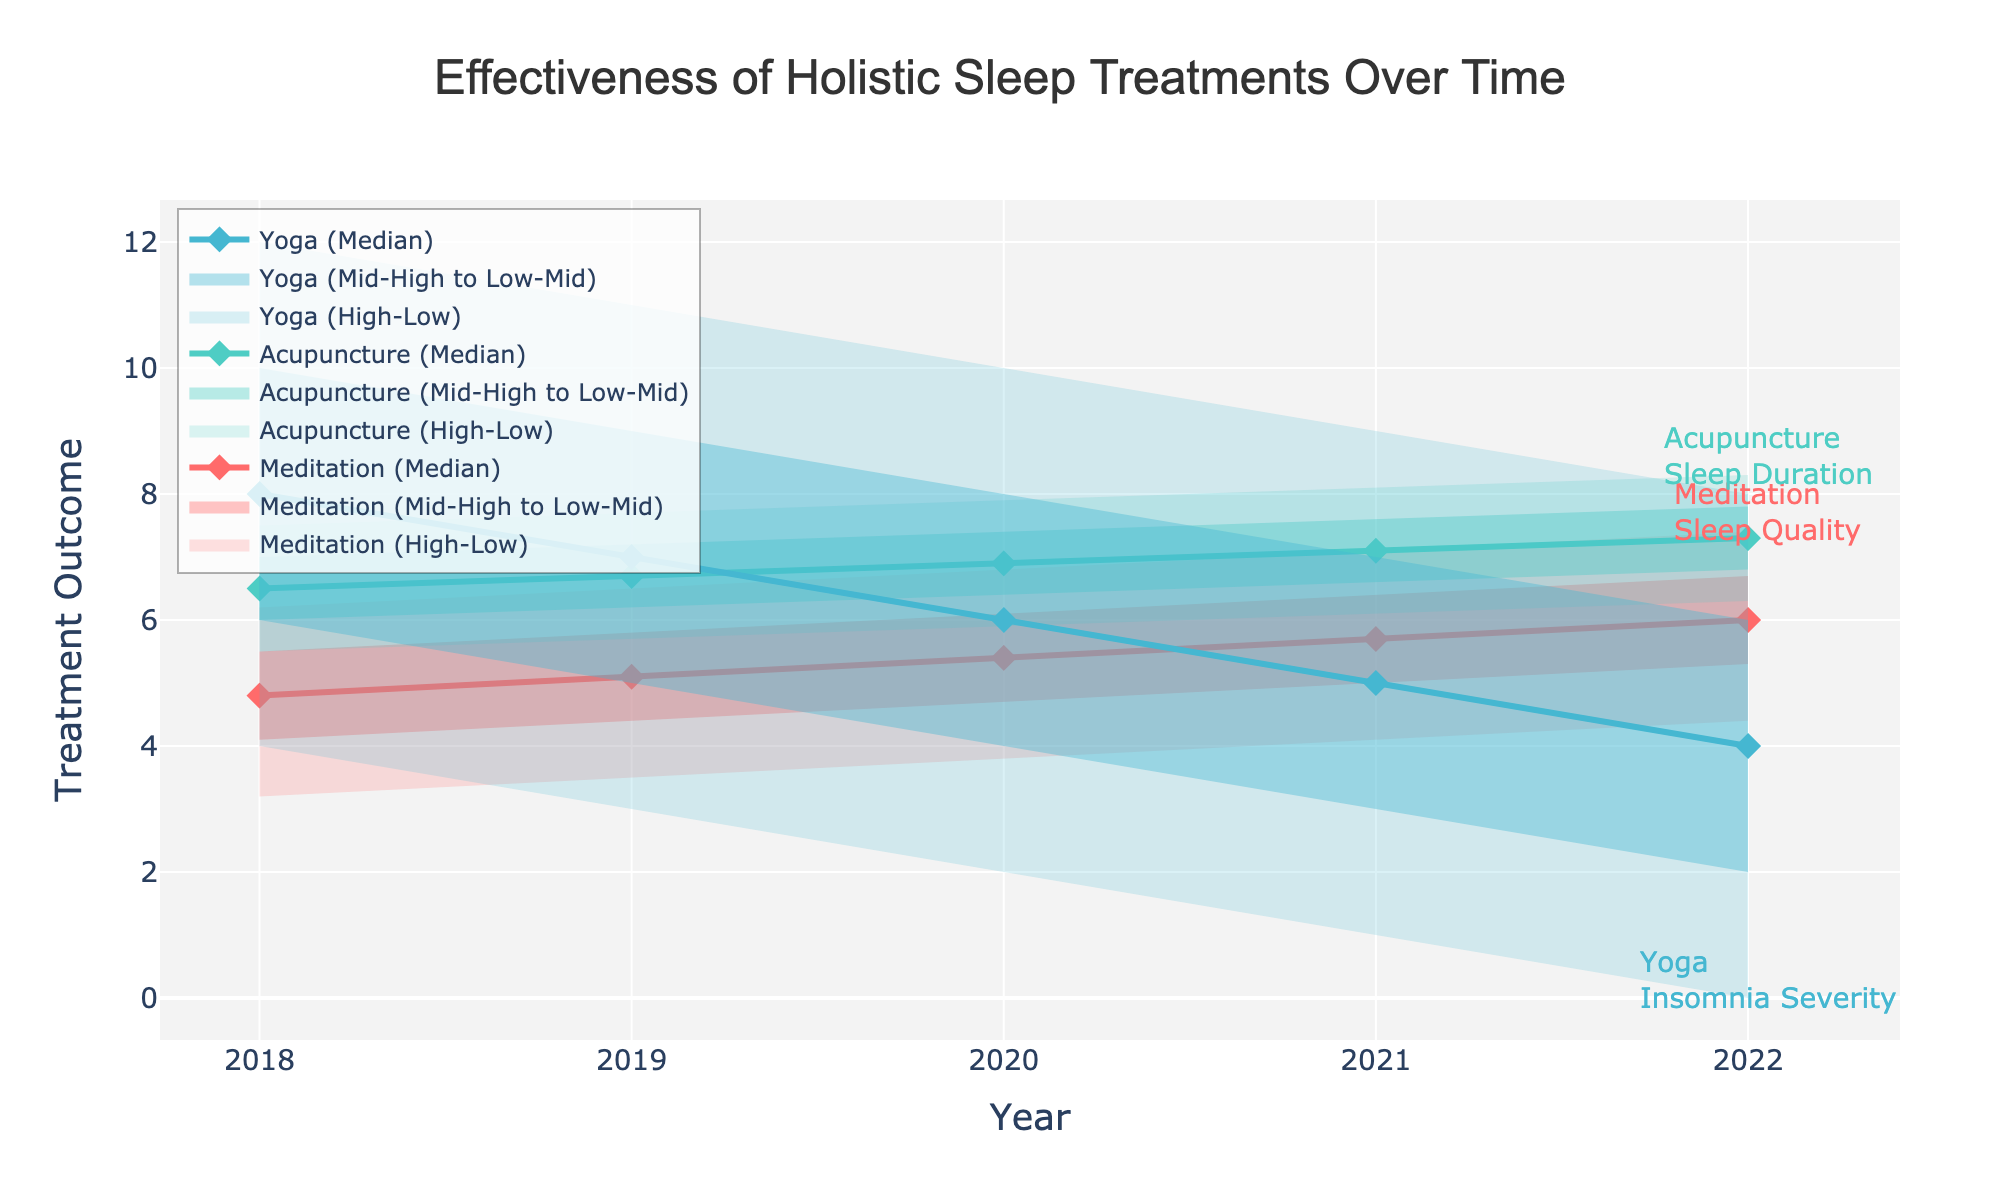What is the time range shown in the figure? The x-axis represents the years ranging from 2018 to 2022.
Answer: 2018 to 2022 What are the three holistic treatments compared in the figure? By looking at the legend and annotation, the treatments compared are Meditation, Acupuncture, and Yoga.
Answer: Meditation, Acupuncture, Yoga Which treatment shows a reduction in insomnia severity over time? By observing the y-axis and annotations, Yoga shows a reduction in insomnia severity from 12 in 2018 to 0 in 2022.
Answer: Yoga What was the median sleep quality outcome for meditation in 2020? You can find the specific point on the chart for the year 2020 under the "Meditation" section. The median sleep quality outcome for meditation in 2020 was 5.4.
Answer: 5.4 In 2022, which treatment had the highest "high" range for its outcome? By observing the top edge of the "high" range in 2022, Acupuncture had the highest "high" range for Sleep Duration with a value of 8.3.
Answer: Acupuncture How did the median sleep duration outcome for acupuncture change from 2018 to 2022? The median sleep duration for acupuncture increased from 6.5 in 2018 to 7.3 in 2022. The change can be calculated as 7.3 - 6.5 = 0.8.
Answer: Increased by 0.8 Which treatment has the most adaptable outcomes (largest spread) in 2022? By looking at the spread between the "Low" and "High" values in 2022, Meditation has the largest spread (4.4 to 7.4), which is a difference of 3.0.
Answer: Meditation Which treatment showed the most consistent improvement in its outcome across all years? From the visual trend, Yoga showed a consistent improvement as the Insomnia Severity decreased steadily from 12 in 2018 to 0 in 2022.
Answer: Yoga How did the low sleep quality outcome for meditation change from 2018 to 2022? The low sleep quality outcome for meditation increased from 3.2 in 2018 to 4.4 in 2022, an increase of 4.4 - 3.2 = 1.2.
Answer: Increased by 1.2 